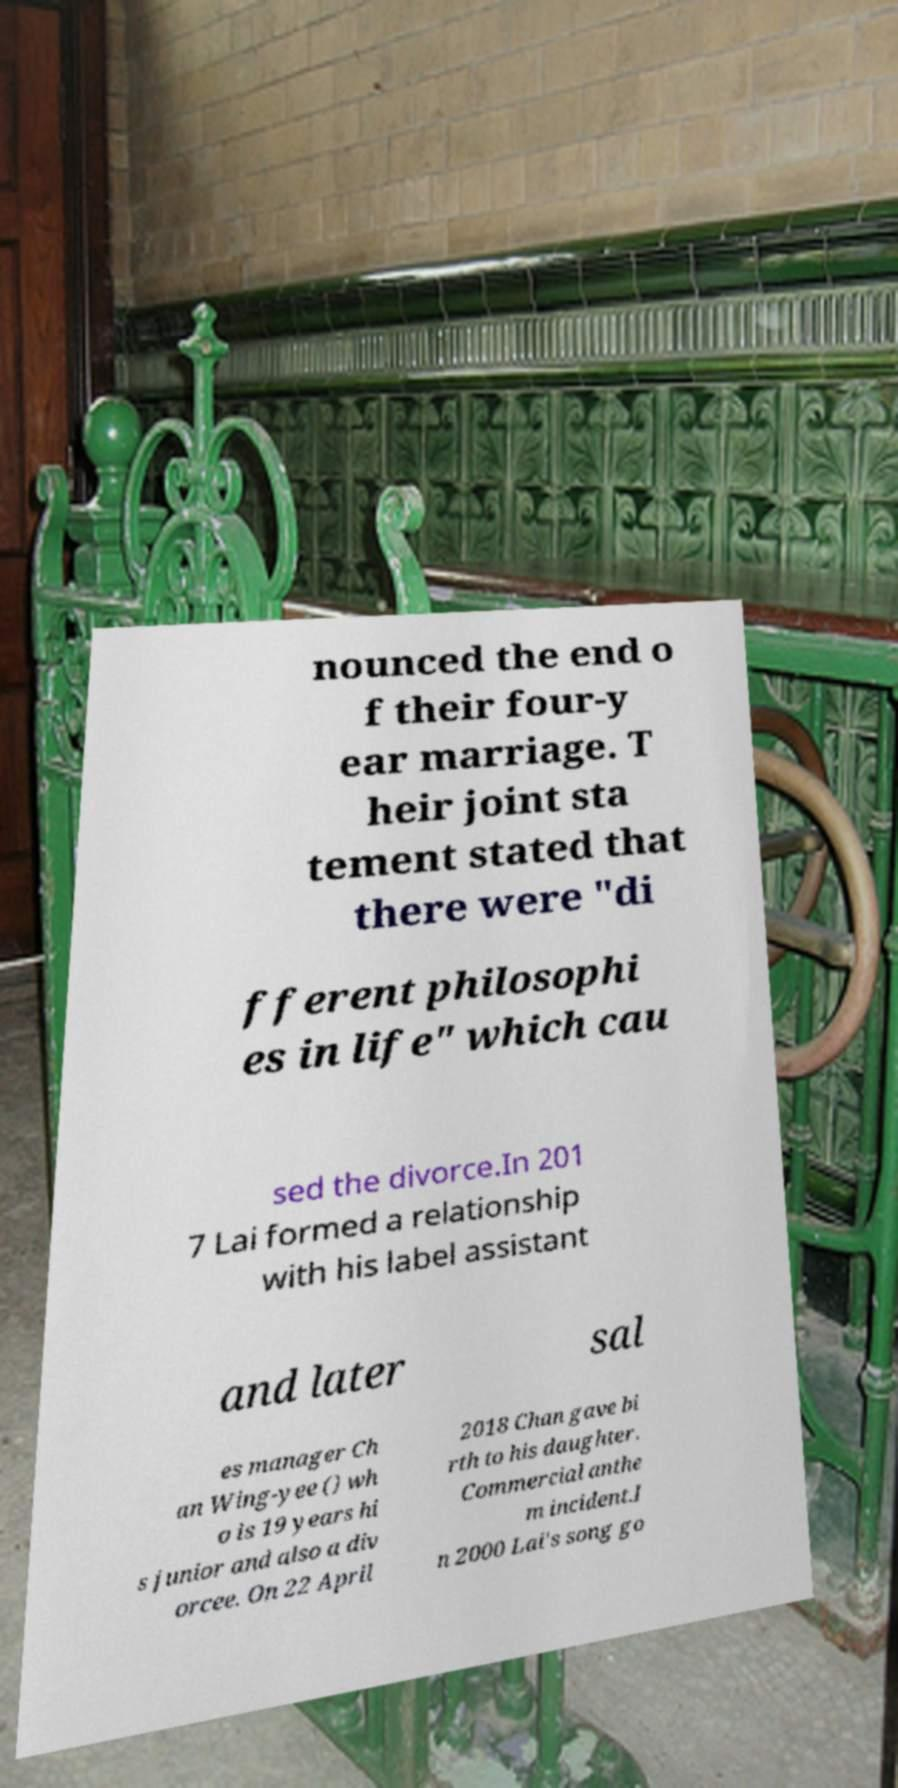Can you accurately transcribe the text from the provided image for me? nounced the end o f their four-y ear marriage. T heir joint sta tement stated that there were "di fferent philosophi es in life" which cau sed the divorce.In 201 7 Lai formed a relationship with his label assistant and later sal es manager Ch an Wing-yee () wh o is 19 years hi s junior and also a div orcee. On 22 April 2018 Chan gave bi rth to his daughter. Commercial anthe m incident.I n 2000 Lai's song go 